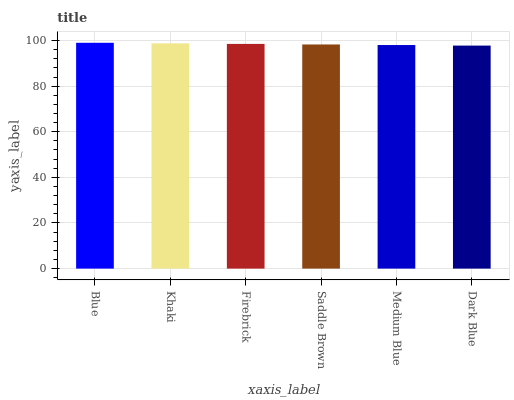Is Dark Blue the minimum?
Answer yes or no. Yes. Is Blue the maximum?
Answer yes or no. Yes. Is Khaki the minimum?
Answer yes or no. No. Is Khaki the maximum?
Answer yes or no. No. Is Blue greater than Khaki?
Answer yes or no. Yes. Is Khaki less than Blue?
Answer yes or no. Yes. Is Khaki greater than Blue?
Answer yes or no. No. Is Blue less than Khaki?
Answer yes or no. No. Is Firebrick the high median?
Answer yes or no. Yes. Is Saddle Brown the low median?
Answer yes or no. Yes. Is Saddle Brown the high median?
Answer yes or no. No. Is Dark Blue the low median?
Answer yes or no. No. 